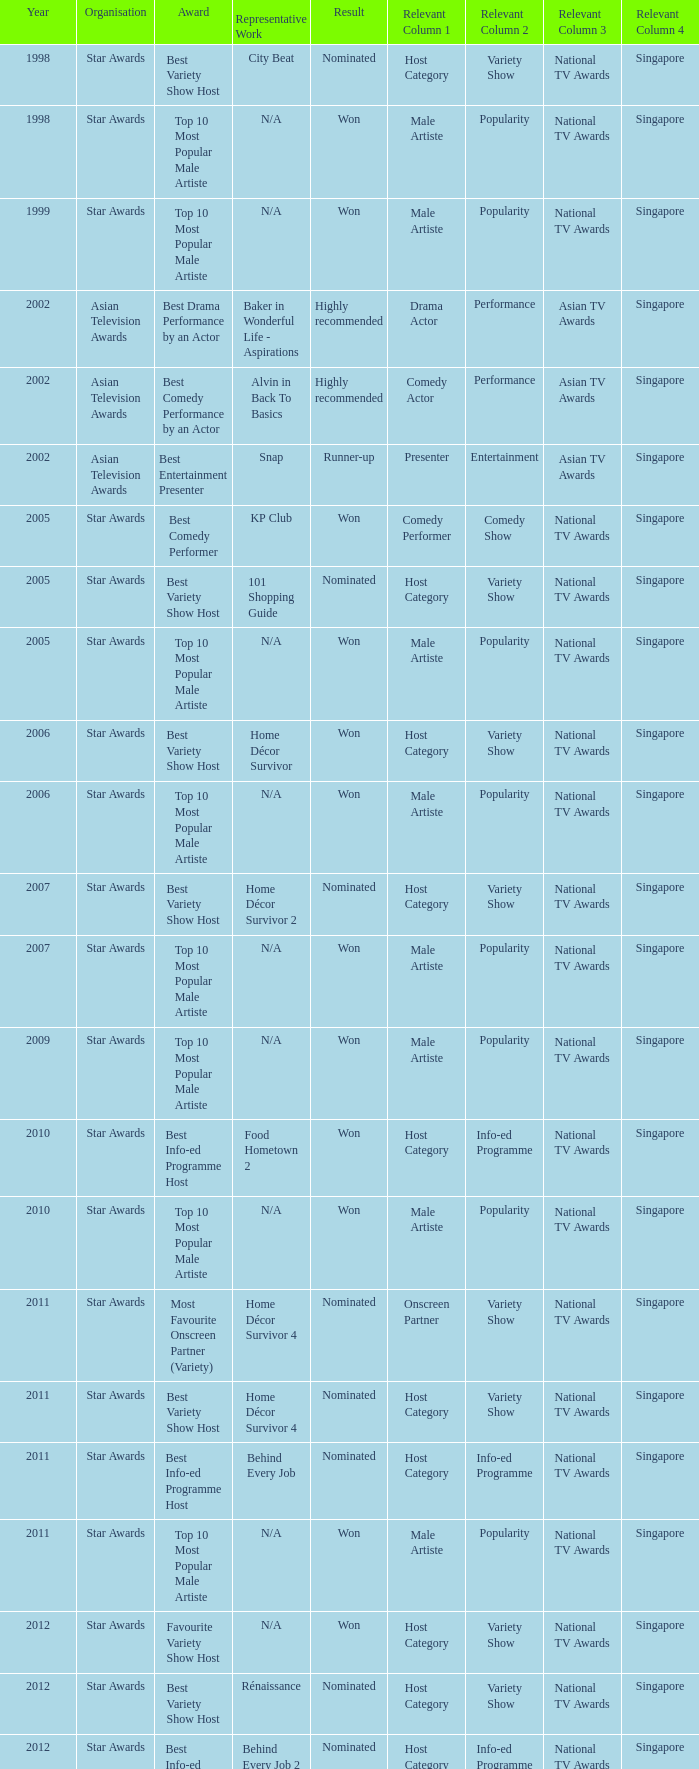What is the award for 1998 with Representative Work of city beat? Best Variety Show Host. 